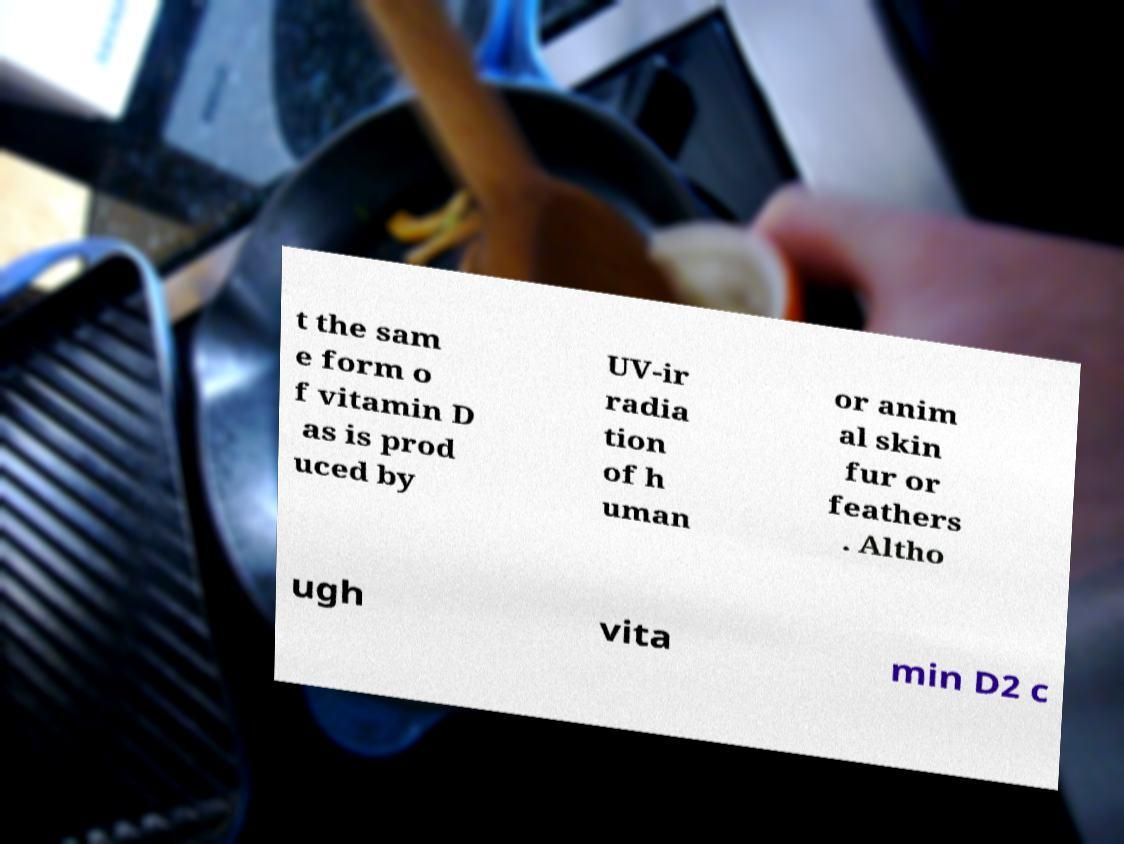There's text embedded in this image that I need extracted. Can you transcribe it verbatim? t the sam e form o f vitamin D as is prod uced by UV-ir radia tion of h uman or anim al skin fur or feathers . Altho ugh vita min D2 c 